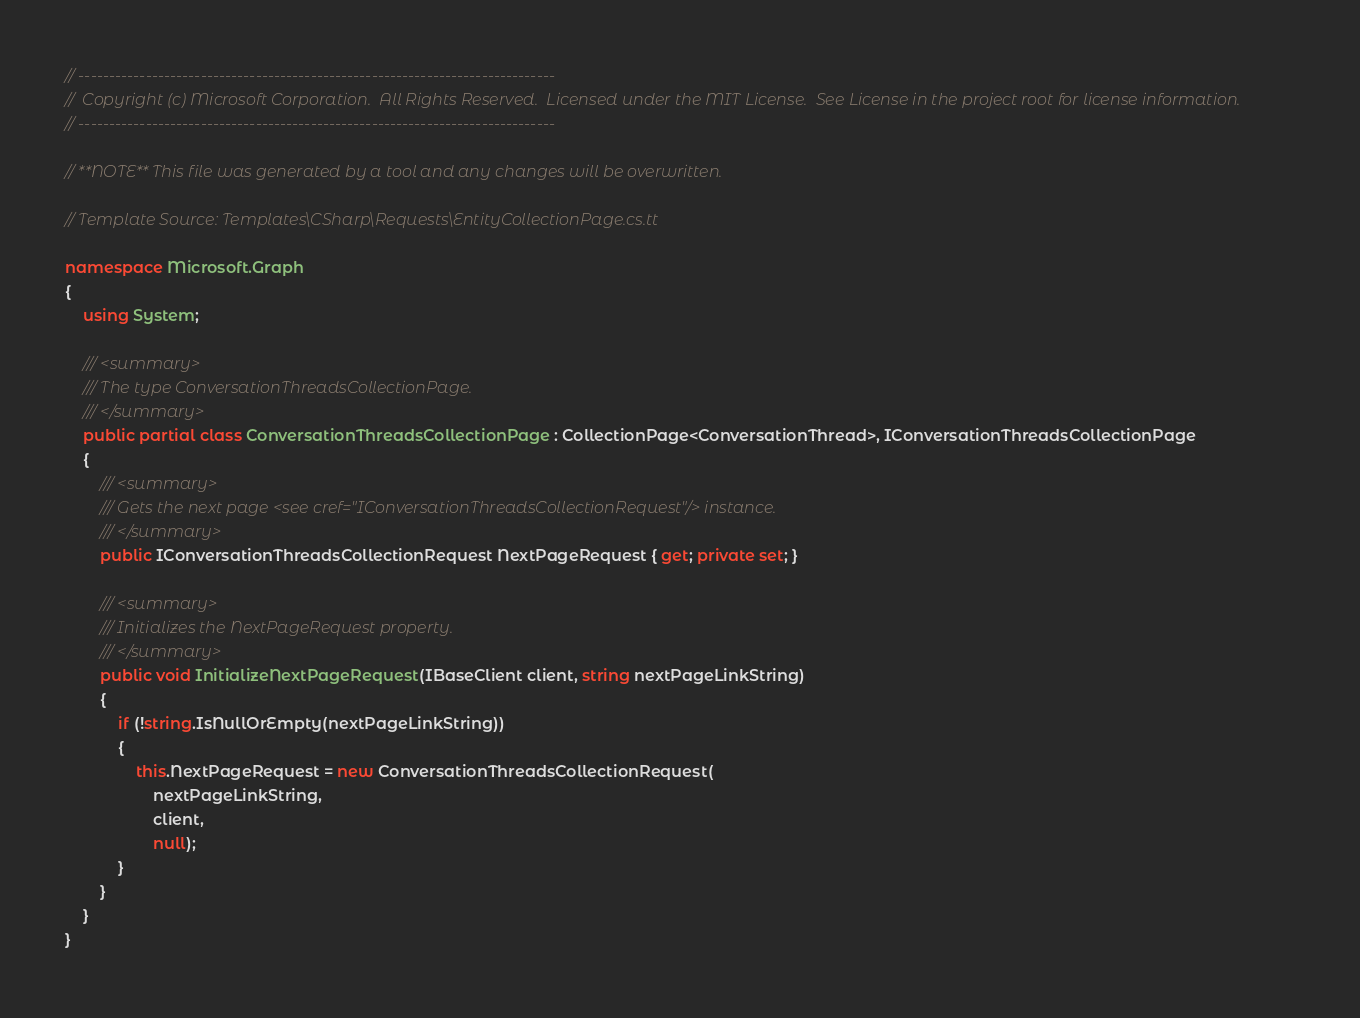<code> <loc_0><loc_0><loc_500><loc_500><_C#_>// ------------------------------------------------------------------------------
//  Copyright (c) Microsoft Corporation.  All Rights Reserved.  Licensed under the MIT License.  See License in the project root for license information.
// ------------------------------------------------------------------------------

// **NOTE** This file was generated by a tool and any changes will be overwritten.

// Template Source: Templates\CSharp\Requests\EntityCollectionPage.cs.tt

namespace Microsoft.Graph
{
    using System;

    /// <summary>
    /// The type ConversationThreadsCollectionPage.
    /// </summary>
    public partial class ConversationThreadsCollectionPage : CollectionPage<ConversationThread>, IConversationThreadsCollectionPage
    {
        /// <summary>
        /// Gets the next page <see cref="IConversationThreadsCollectionRequest"/> instance.
        /// </summary>
        public IConversationThreadsCollectionRequest NextPageRequest { get; private set; }

        /// <summary>
        /// Initializes the NextPageRequest property.
        /// </summary>
        public void InitializeNextPageRequest(IBaseClient client, string nextPageLinkString)
        {
            if (!string.IsNullOrEmpty(nextPageLinkString))
            {
                this.NextPageRequest = new ConversationThreadsCollectionRequest(
                    nextPageLinkString,
                    client,
                    null);
            }
        }
    }
}
</code> 